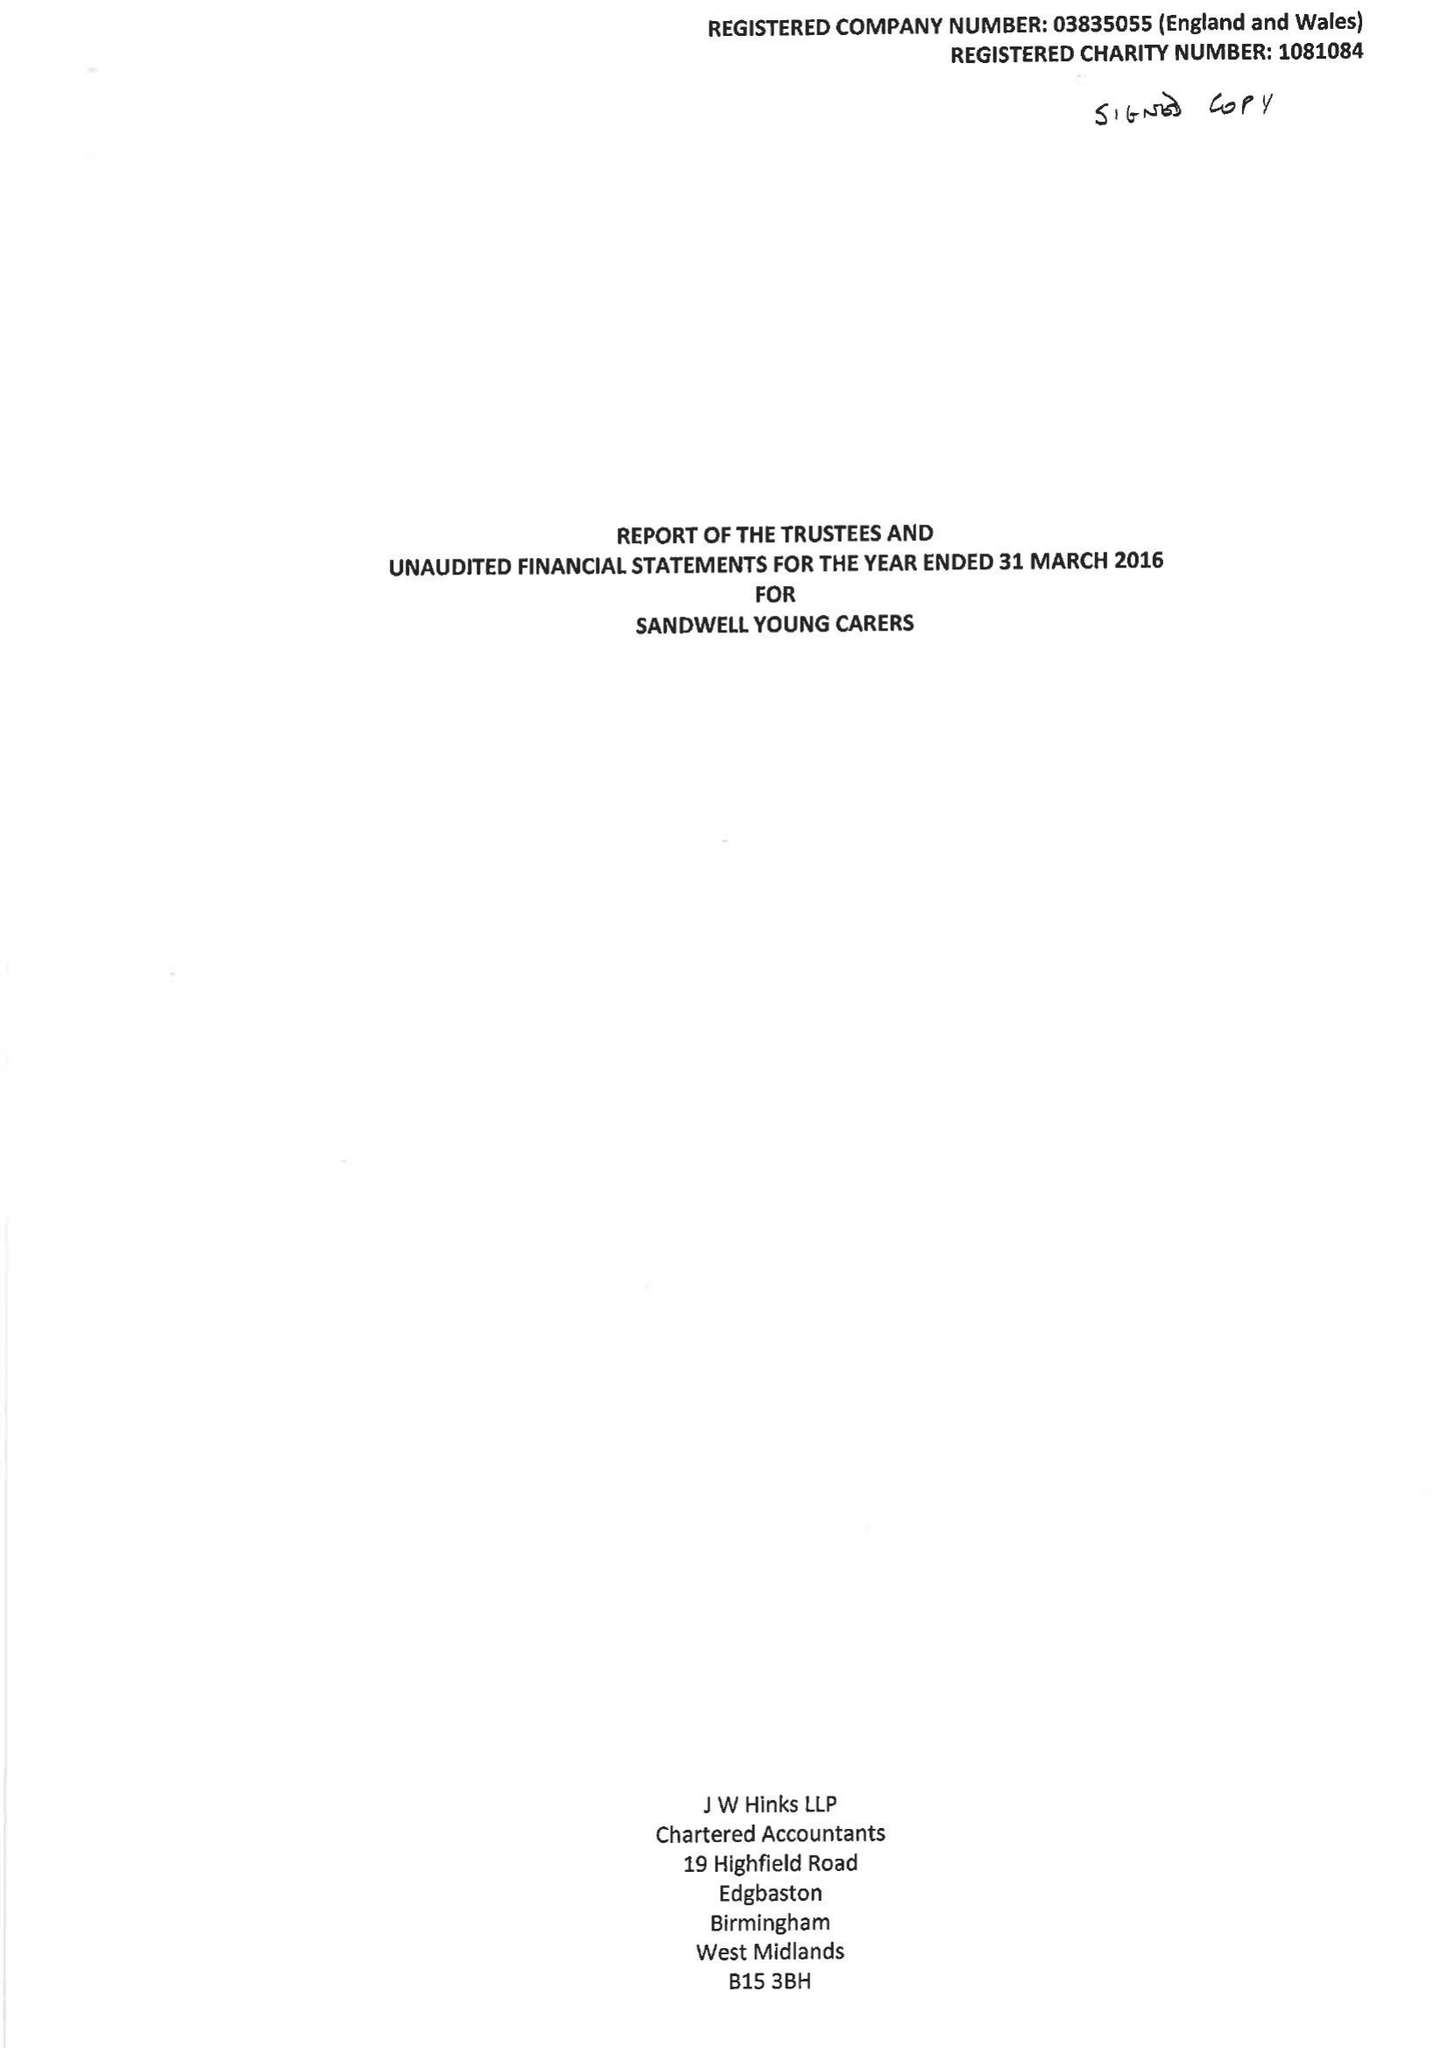What is the value for the address__postcode?
Answer the question using a single word or phrase. B70 8SB 